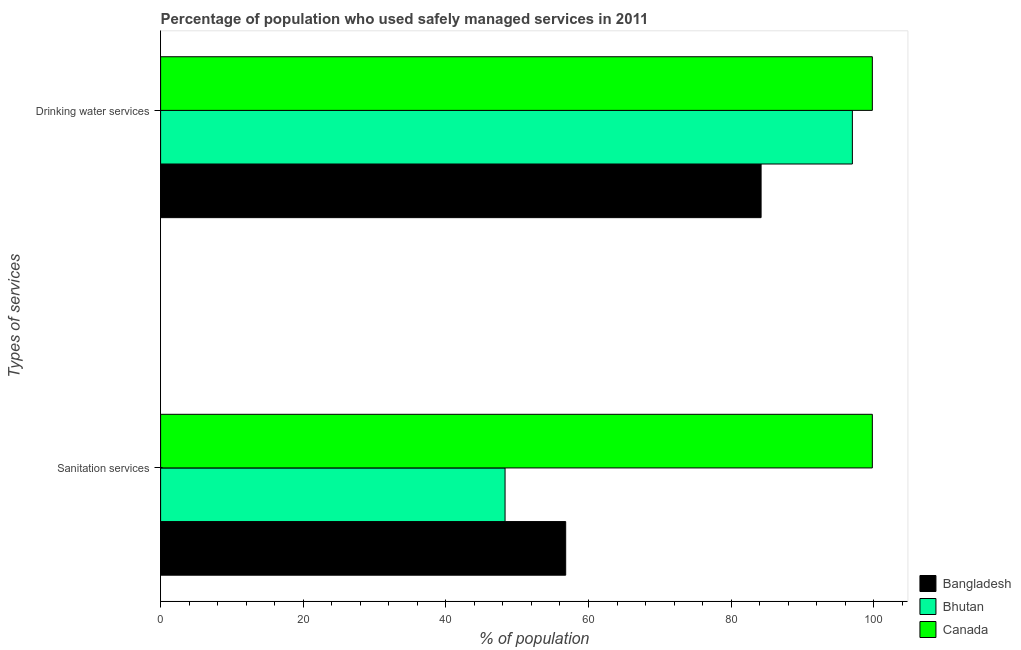How many different coloured bars are there?
Keep it short and to the point. 3. How many groups of bars are there?
Your answer should be compact. 2. Are the number of bars per tick equal to the number of legend labels?
Make the answer very short. Yes. How many bars are there on the 2nd tick from the top?
Your answer should be very brief. 3. What is the label of the 2nd group of bars from the top?
Make the answer very short. Sanitation services. What is the percentage of population who used drinking water services in Bangladesh?
Offer a terse response. 84.2. Across all countries, what is the maximum percentage of population who used sanitation services?
Keep it short and to the point. 99.8. Across all countries, what is the minimum percentage of population who used sanitation services?
Make the answer very short. 48.3. What is the total percentage of population who used drinking water services in the graph?
Give a very brief answer. 281. What is the difference between the percentage of population who used sanitation services in Canada and the percentage of population who used drinking water services in Bangladesh?
Give a very brief answer. 15.6. What is the average percentage of population who used sanitation services per country?
Provide a short and direct response. 68.3. What is the difference between the percentage of population who used drinking water services and percentage of population who used sanitation services in Bangladesh?
Offer a terse response. 27.4. In how many countries, is the percentage of population who used sanitation services greater than 92 %?
Provide a short and direct response. 1. What is the ratio of the percentage of population who used drinking water services in Bangladesh to that in Canada?
Make the answer very short. 0.84. Is the percentage of population who used sanitation services in Bhutan less than that in Bangladesh?
Provide a short and direct response. Yes. What does the 1st bar from the bottom in Drinking water services represents?
Your answer should be compact. Bangladesh. What is the difference between two consecutive major ticks on the X-axis?
Keep it short and to the point. 20. What is the title of the graph?
Offer a terse response. Percentage of population who used safely managed services in 2011. Does "Cayman Islands" appear as one of the legend labels in the graph?
Make the answer very short. No. What is the label or title of the X-axis?
Give a very brief answer. % of population. What is the label or title of the Y-axis?
Give a very brief answer. Types of services. What is the % of population in Bangladesh in Sanitation services?
Your response must be concise. 56.8. What is the % of population in Bhutan in Sanitation services?
Offer a very short reply. 48.3. What is the % of population of Canada in Sanitation services?
Give a very brief answer. 99.8. What is the % of population in Bangladesh in Drinking water services?
Your answer should be very brief. 84.2. What is the % of population of Bhutan in Drinking water services?
Your answer should be compact. 97. What is the % of population in Canada in Drinking water services?
Make the answer very short. 99.8. Across all Types of services, what is the maximum % of population of Bangladesh?
Keep it short and to the point. 84.2. Across all Types of services, what is the maximum % of population of Bhutan?
Ensure brevity in your answer.  97. Across all Types of services, what is the maximum % of population in Canada?
Your response must be concise. 99.8. Across all Types of services, what is the minimum % of population of Bangladesh?
Provide a short and direct response. 56.8. Across all Types of services, what is the minimum % of population in Bhutan?
Offer a very short reply. 48.3. Across all Types of services, what is the minimum % of population in Canada?
Your response must be concise. 99.8. What is the total % of population of Bangladesh in the graph?
Provide a short and direct response. 141. What is the total % of population in Bhutan in the graph?
Keep it short and to the point. 145.3. What is the total % of population of Canada in the graph?
Your answer should be compact. 199.6. What is the difference between the % of population in Bangladesh in Sanitation services and that in Drinking water services?
Give a very brief answer. -27.4. What is the difference between the % of population in Bhutan in Sanitation services and that in Drinking water services?
Give a very brief answer. -48.7. What is the difference between the % of population in Canada in Sanitation services and that in Drinking water services?
Keep it short and to the point. 0. What is the difference between the % of population in Bangladesh in Sanitation services and the % of population in Bhutan in Drinking water services?
Offer a terse response. -40.2. What is the difference between the % of population of Bangladesh in Sanitation services and the % of population of Canada in Drinking water services?
Provide a short and direct response. -43. What is the difference between the % of population of Bhutan in Sanitation services and the % of population of Canada in Drinking water services?
Ensure brevity in your answer.  -51.5. What is the average % of population in Bangladesh per Types of services?
Provide a short and direct response. 70.5. What is the average % of population of Bhutan per Types of services?
Provide a short and direct response. 72.65. What is the average % of population of Canada per Types of services?
Offer a terse response. 99.8. What is the difference between the % of population in Bangladesh and % of population in Canada in Sanitation services?
Provide a short and direct response. -43. What is the difference between the % of population of Bhutan and % of population of Canada in Sanitation services?
Provide a short and direct response. -51.5. What is the difference between the % of population in Bangladesh and % of population in Bhutan in Drinking water services?
Offer a very short reply. -12.8. What is the difference between the % of population in Bangladesh and % of population in Canada in Drinking water services?
Ensure brevity in your answer.  -15.6. What is the ratio of the % of population of Bangladesh in Sanitation services to that in Drinking water services?
Your response must be concise. 0.67. What is the ratio of the % of population in Bhutan in Sanitation services to that in Drinking water services?
Make the answer very short. 0.5. What is the difference between the highest and the second highest % of population in Bangladesh?
Ensure brevity in your answer.  27.4. What is the difference between the highest and the second highest % of population in Bhutan?
Give a very brief answer. 48.7. What is the difference between the highest and the lowest % of population of Bangladesh?
Your answer should be very brief. 27.4. What is the difference between the highest and the lowest % of population of Bhutan?
Offer a terse response. 48.7. 